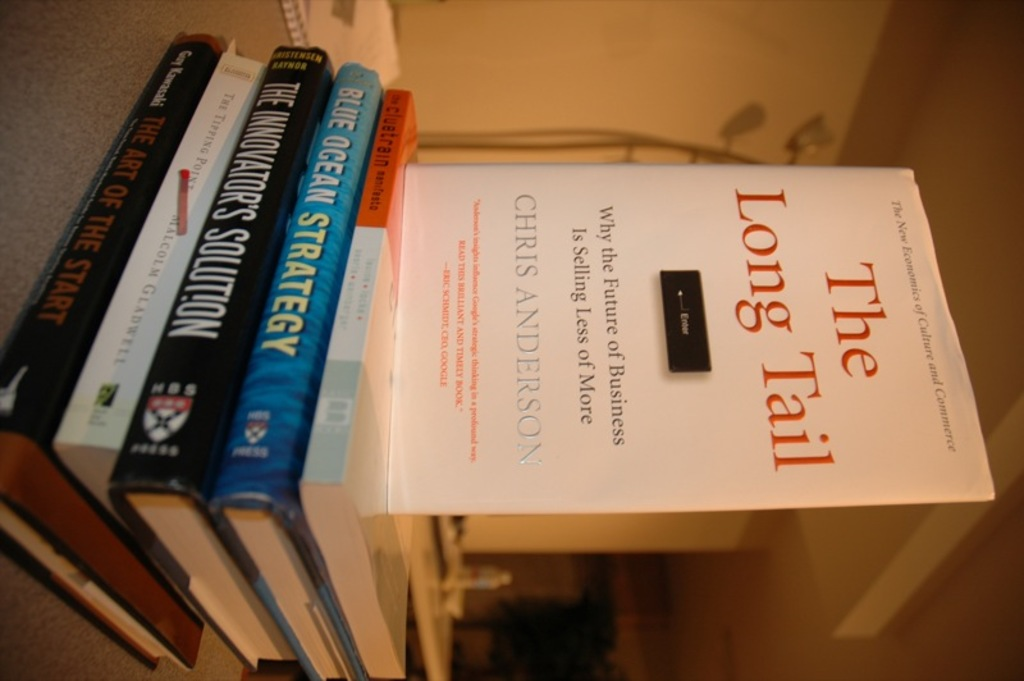Explain the visual content of the image in great detail. The image captures a shelf displaying a focused selection of impactful business literature. The centerpiece is 'The Long Tail: Why the Future of Business is Selling Less of More' by Chris Anderson, oriented such that the viewer can read the cover vertically. This book introduces a contrarian view that a significant portion of a market's sales can come from niche products rather than mainstream hits. Just beneath it, two vital reads in business strategy, 'The Innovator's Solution' by Clayton M. Christensen and 'Blue Ocean Strategy' by W. Chan Kim and Renée Mauborgne, are visible with their spines facing outward. Their position and prominence suggest a thematic coordination focused on innovative and strategic thinking in business. The neatly arranged books, and the organized setting with a beige backdrop, evoke a sense of intellectual order and focus. 